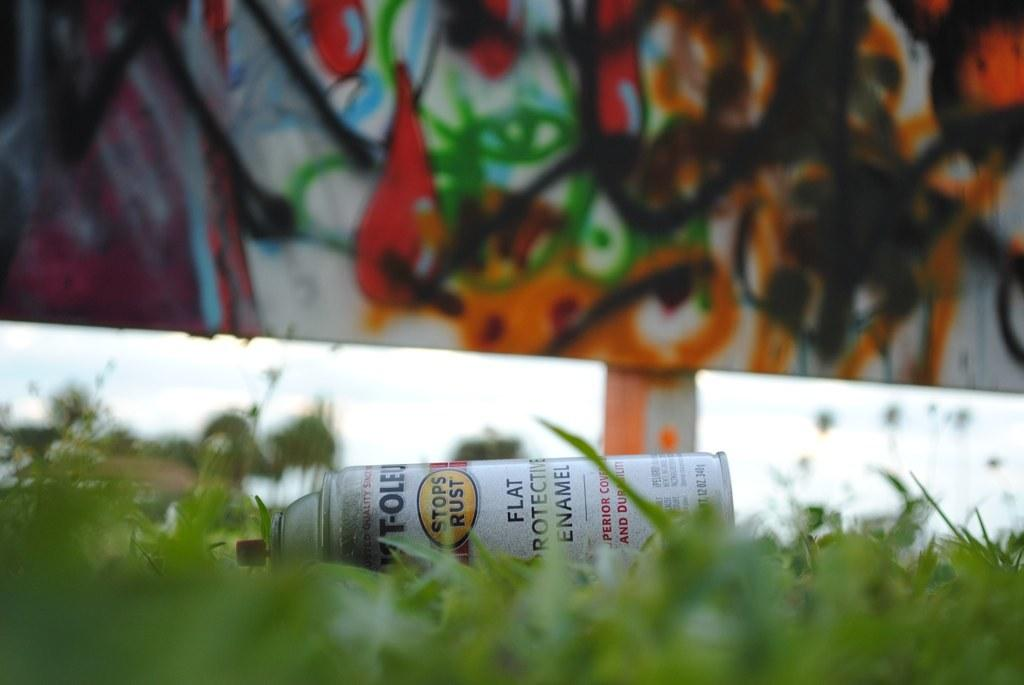<image>
Create a compact narrative representing the image presented. A can of spray paint is sitting in the grass 